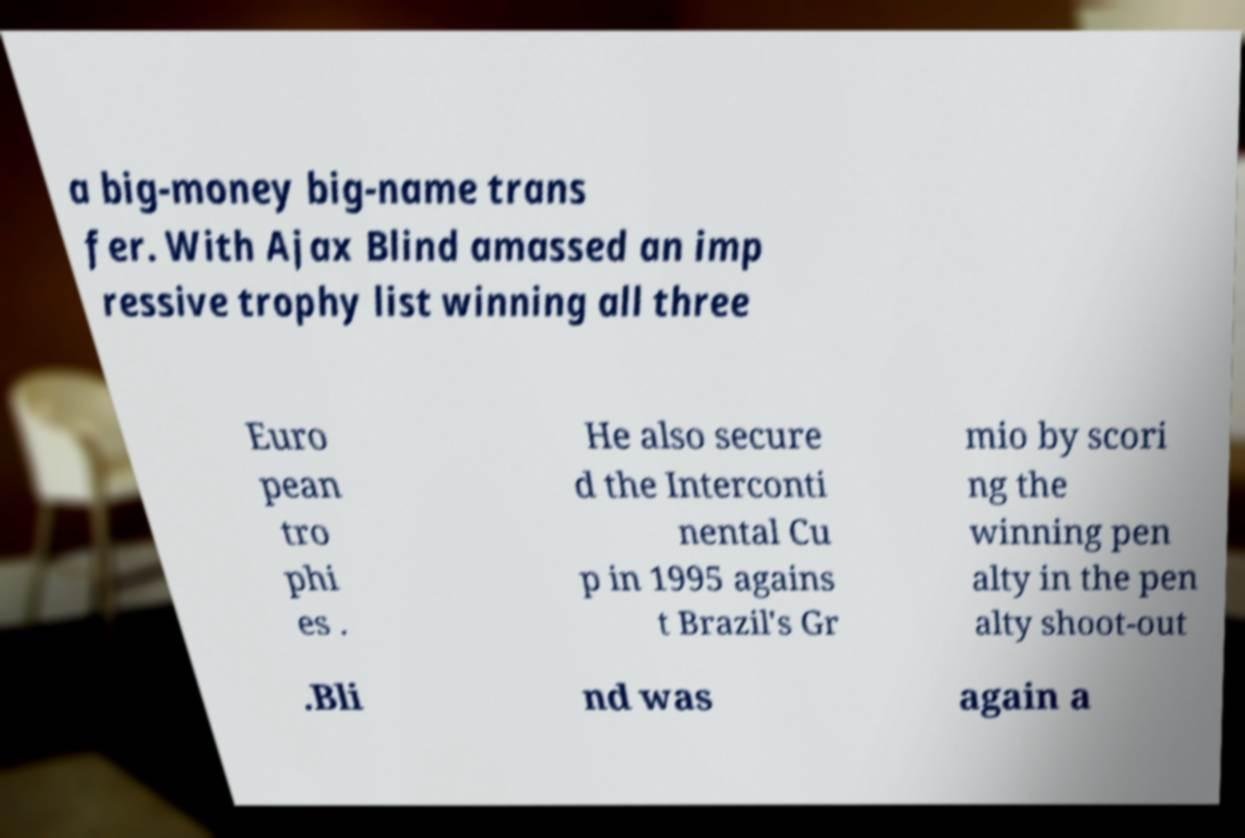Could you assist in decoding the text presented in this image and type it out clearly? a big-money big-name trans fer. With Ajax Blind amassed an imp ressive trophy list winning all three Euro pean tro phi es . He also secure d the Interconti nental Cu p in 1995 agains t Brazil's Gr mio by scori ng the winning pen alty in the pen alty shoot-out .Bli nd was again a 